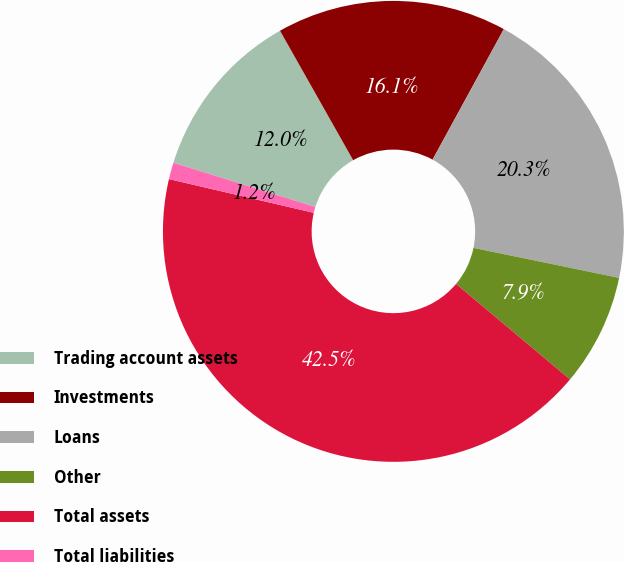Convert chart. <chart><loc_0><loc_0><loc_500><loc_500><pie_chart><fcel>Trading account assets<fcel>Investments<fcel>Loans<fcel>Other<fcel>Total assets<fcel>Total liabilities<nl><fcel>12.0%<fcel>16.14%<fcel>20.28%<fcel>7.87%<fcel>42.54%<fcel>1.17%<nl></chart> 